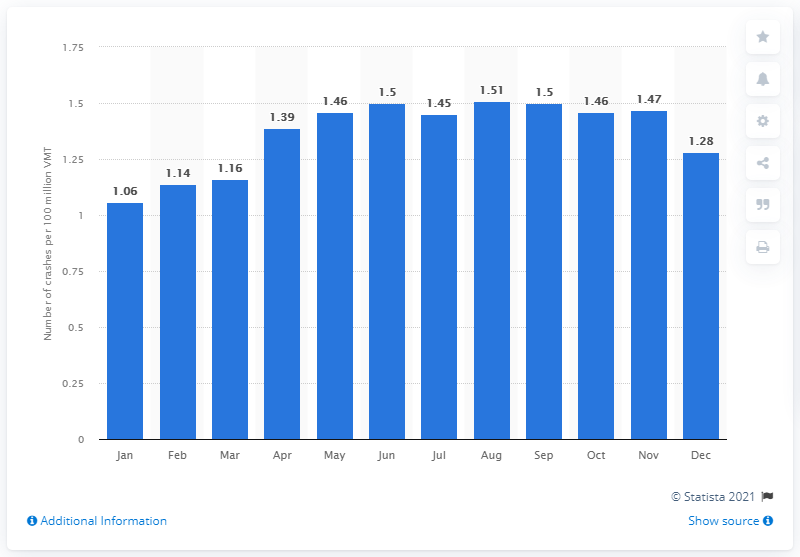Indicate a few pertinent items in this graphic. According to the data, the crash rate in December of 2020 was 1.28. 